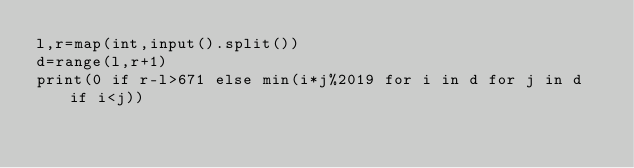Convert code to text. <code><loc_0><loc_0><loc_500><loc_500><_Python_>l,r=map(int,input().split())
d=range(l,r+1)
print(0 if r-l>671 else min(i*j%2019 for i in d for j in d if i<j))</code> 